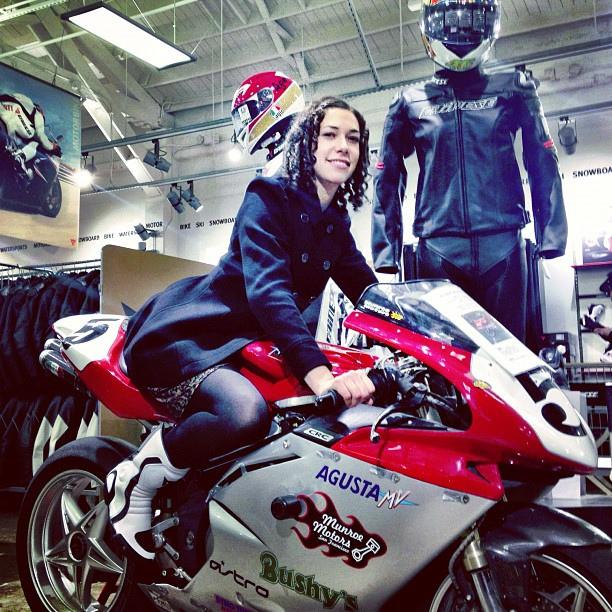How many people are in this photo?
Be succinct. 1. What kind of motorcycle?
Quick response, please. Augusta. Is the girl wearing jeans?
Answer briefly. No. 